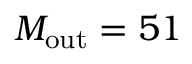Convert formula to latex. <formula><loc_0><loc_0><loc_500><loc_500>M _ { o u t } = 5 1</formula> 